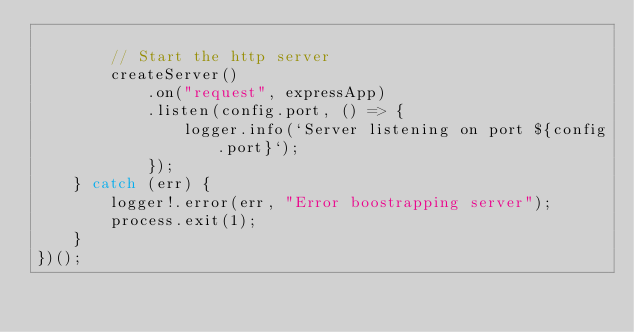<code> <loc_0><loc_0><loc_500><loc_500><_TypeScript_>
        // Start the http server
        createServer()
            .on("request", expressApp)
            .listen(config.port, () => {
                logger.info(`Server listening on port ${config.port}`);
            });
    } catch (err) {
        logger!.error(err, "Error boostrapping server");
        process.exit(1);
    }
})();
</code> 